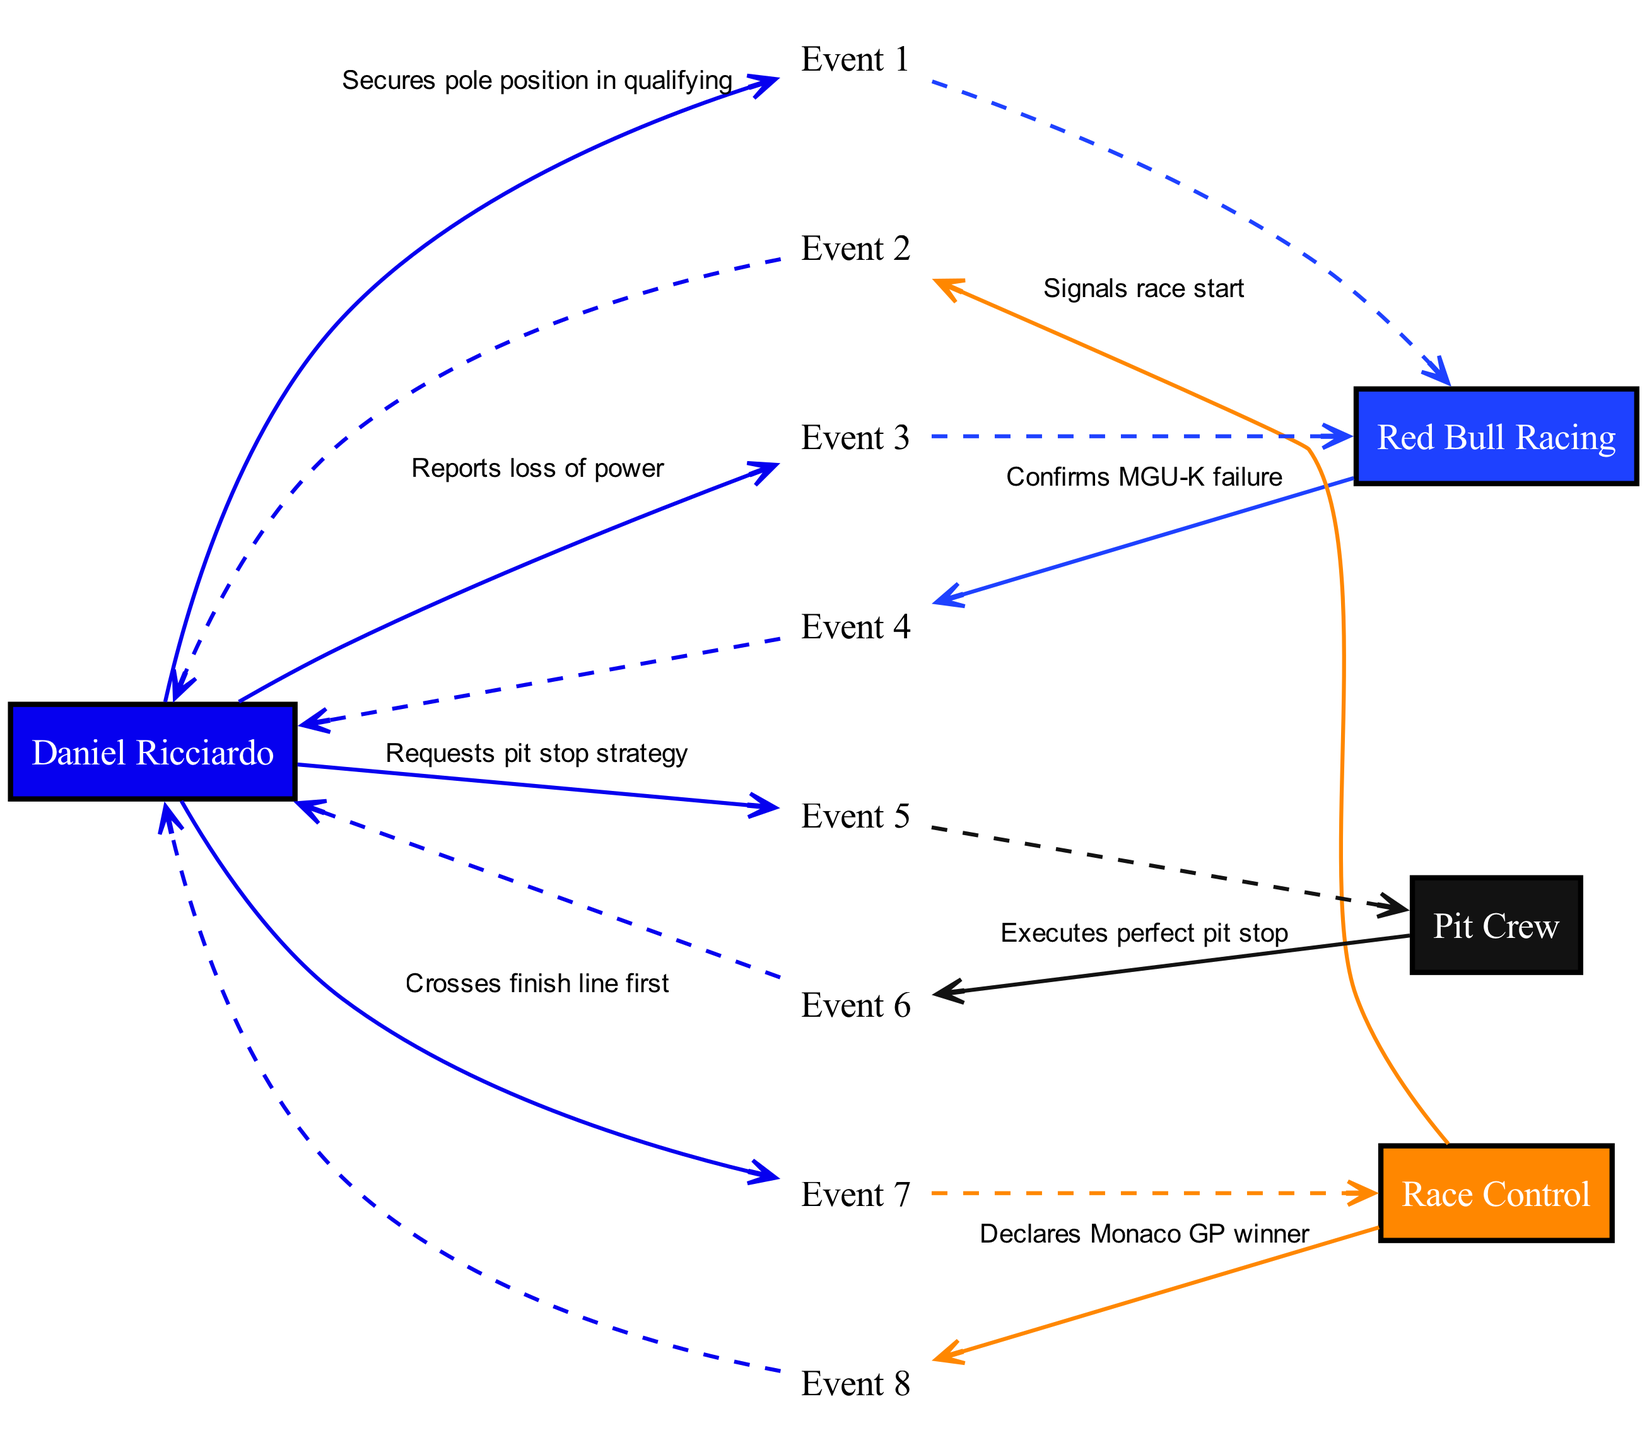What action does Daniel Ricciardo take after securing pole position? Daniel Ricciardo reports a loss of power to Red Bull Racing, indicating a problem with the car after successfully securing the pole position in qualifying.
Answer: Reports loss of power How many events are represented in the sequence diagram? The sequence diagram includes a total of eight events that track the interactions and actions taken by Daniel Ricciardo, Red Bull Racing, Race Control, and the Pit Crew.
Answer: Eight What failure is confirmed by Red Bull Racing? Red Bull Racing confirms an MGU-K failure after Daniel Ricciardo reports a loss of power during the race, which indicates a mechanical issue affecting the car's performance.
Answer: MGU-K failure Who executes the perfect pit stop for Ricciardo? The pit crew is responsible for executing the perfect pit stop for Daniel Ricciardo, which plays a crucial role in his strategy during the race.
Answer: Pit Crew What event marks the conclusion of the race for Daniel Ricciardo? The conclusion of the race for Daniel Ricciardo is marked by crossing the finish line first, which is a key moment in securing his victory at the Monaco Grand Prix.
Answer: Crosses finish line first Which entity declares Daniel Ricciardo as the winner? Race Control declares Daniel Ricciardo as the winner of the Monaco Grand Prix after he crosses the finish line first, signaling the completion of the race.
Answer: Race Control What request does Daniel Ricciardo make to the Pit Crew? Daniel Ricciardo requests a pit stop strategy, indicating that he seeks guidance from the Pit Crew on how to manage his tire changes and timing during the race.
Answer: Requests pit stop strategy Which actor indicates the start of the race? Race Control signals the start of the race, which initiates the sequence of events leading up to Daniel Ricciardo's victory.
Answer: Race Control What sequence of actors follows the event of Daniel Ricciardo crossing the finish line? Following the event of crossing the finish line, Race Control is the actor that declares him the winner, showcasing the relationship and sequence of events leading to the conclusion of the race.
Answer: Race Control 